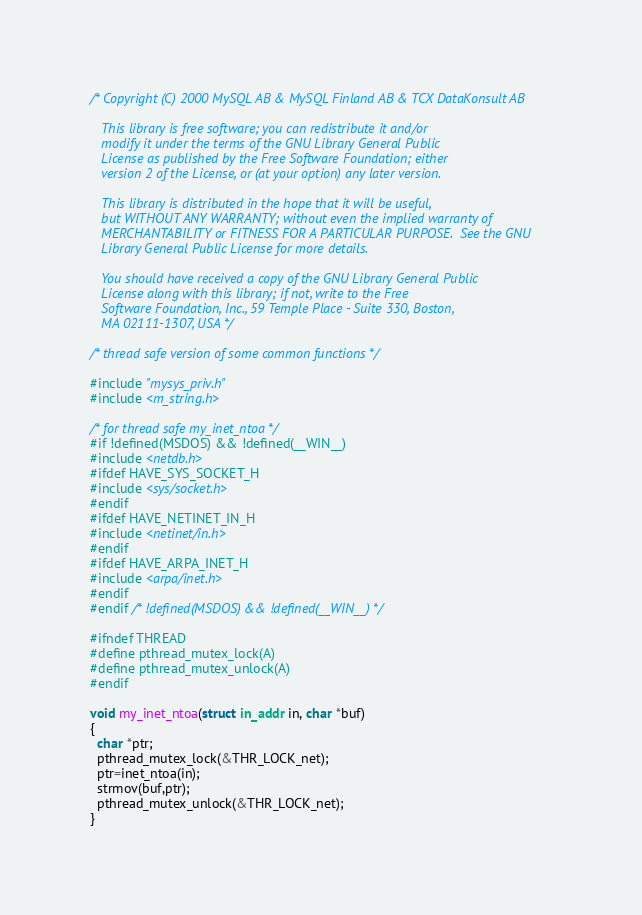Convert code to text. <code><loc_0><loc_0><loc_500><loc_500><_C_>/* Copyright (C) 2000 MySQL AB & MySQL Finland AB & TCX DataKonsult AB
   
   This library is free software; you can redistribute it and/or
   modify it under the terms of the GNU Library General Public
   License as published by the Free Software Foundation; either
   version 2 of the License, or (at your option) any later version.
   
   This library is distributed in the hope that it will be useful,
   but WITHOUT ANY WARRANTY; without even the implied warranty of
   MERCHANTABILITY or FITNESS FOR A PARTICULAR PURPOSE.  See the GNU
   Library General Public License for more details.
   
   You should have received a copy of the GNU Library General Public
   License along with this library; if not, write to the Free
   Software Foundation, Inc., 59 Temple Place - Suite 330, Boston,
   MA 02111-1307, USA */

/* thread safe version of some common functions */

#include "mysys_priv.h"
#include <m_string.h>

/* for thread safe my_inet_ntoa */
#if !defined(MSDOS) && !defined(__WIN__)
#include <netdb.h>
#ifdef HAVE_SYS_SOCKET_H
#include <sys/socket.h>
#endif
#ifdef HAVE_NETINET_IN_H
#include <netinet/in.h>
#endif
#ifdef HAVE_ARPA_INET_H
#include <arpa/inet.h>
#endif
#endif /* !defined(MSDOS) && !defined(__WIN__) */

#ifndef THREAD
#define pthread_mutex_lock(A)
#define pthread_mutex_unlock(A)
#endif

void my_inet_ntoa(struct in_addr in, char *buf)
{
  char *ptr;
  pthread_mutex_lock(&THR_LOCK_net);
  ptr=inet_ntoa(in);
  strmov(buf,ptr);
  pthread_mutex_unlock(&THR_LOCK_net);
}
</code> 